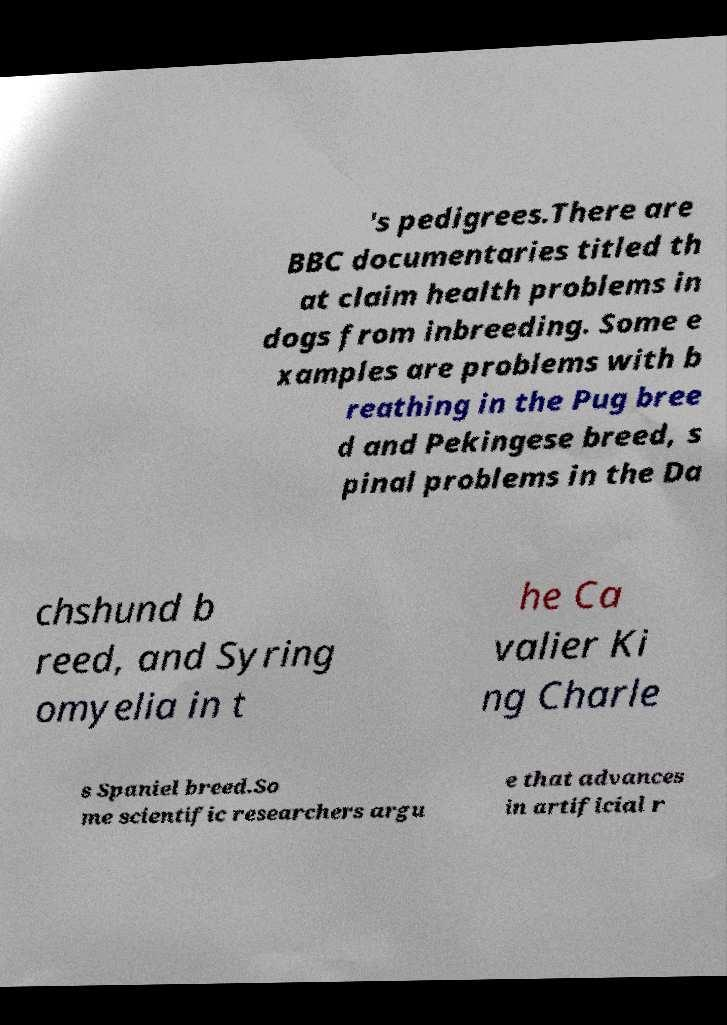Could you extract and type out the text from this image? 's pedigrees.There are BBC documentaries titled th at claim health problems in dogs from inbreeding. Some e xamples are problems with b reathing in the Pug bree d and Pekingese breed, s pinal problems in the Da chshund b reed, and Syring omyelia in t he Ca valier Ki ng Charle s Spaniel breed.So me scientific researchers argu e that advances in artificial r 